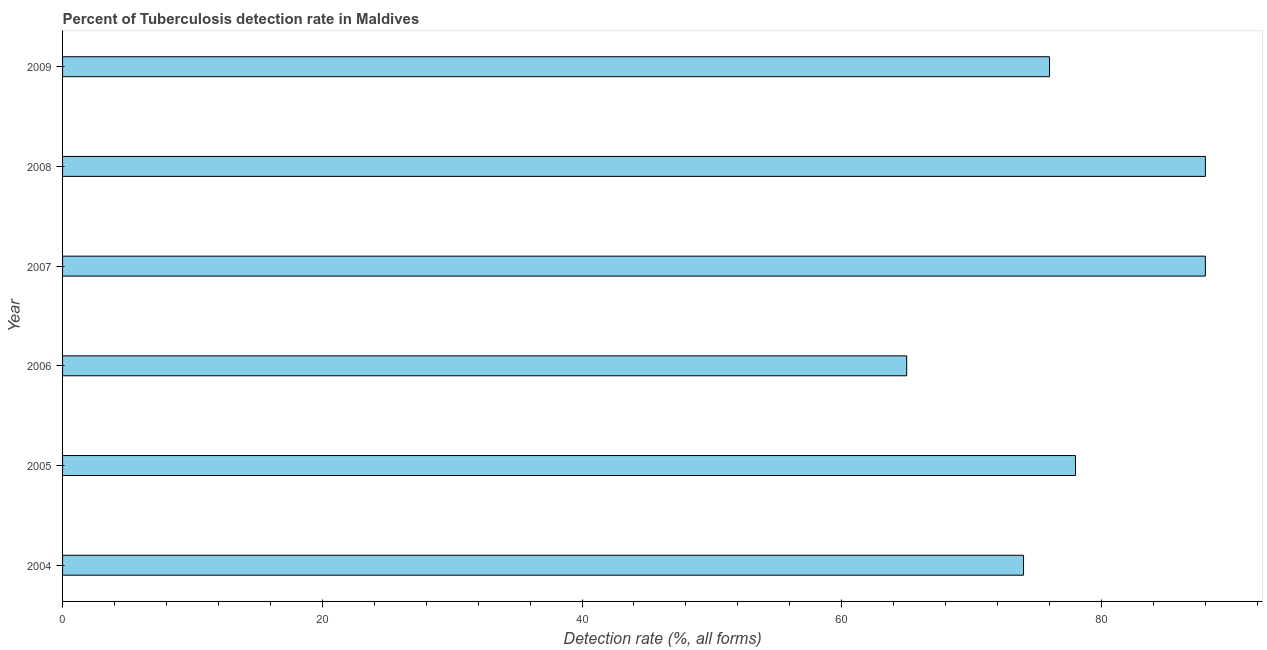Does the graph contain any zero values?
Your answer should be very brief. No. What is the title of the graph?
Provide a short and direct response. Percent of Tuberculosis detection rate in Maldives. What is the label or title of the X-axis?
Offer a terse response. Detection rate (%, all forms). Across all years, what is the maximum detection rate of tuberculosis?
Make the answer very short. 88. Across all years, what is the minimum detection rate of tuberculosis?
Your response must be concise. 65. In which year was the detection rate of tuberculosis maximum?
Your answer should be compact. 2007. In which year was the detection rate of tuberculosis minimum?
Offer a very short reply. 2006. What is the sum of the detection rate of tuberculosis?
Provide a succinct answer. 469. In how many years, is the detection rate of tuberculosis greater than 24 %?
Ensure brevity in your answer.  6. Do a majority of the years between 2009 and 2004 (inclusive) have detection rate of tuberculosis greater than 52 %?
Offer a very short reply. Yes. What is the ratio of the detection rate of tuberculosis in 2004 to that in 2007?
Your answer should be very brief. 0.84. Is the difference between the detection rate of tuberculosis in 2004 and 2007 greater than the difference between any two years?
Offer a terse response. No. What is the difference between the highest and the lowest detection rate of tuberculosis?
Provide a short and direct response. 23. How many bars are there?
Your answer should be compact. 6. Are all the bars in the graph horizontal?
Keep it short and to the point. Yes. How many years are there in the graph?
Give a very brief answer. 6. What is the difference between two consecutive major ticks on the X-axis?
Ensure brevity in your answer.  20. What is the Detection rate (%, all forms) of 2006?
Provide a succinct answer. 65. What is the difference between the Detection rate (%, all forms) in 2004 and 2007?
Provide a short and direct response. -14. What is the difference between the Detection rate (%, all forms) in 2004 and 2008?
Keep it short and to the point. -14. What is the difference between the Detection rate (%, all forms) in 2005 and 2007?
Offer a very short reply. -10. What is the difference between the Detection rate (%, all forms) in 2005 and 2008?
Your answer should be very brief. -10. What is the difference between the Detection rate (%, all forms) in 2006 and 2009?
Your answer should be very brief. -11. What is the difference between the Detection rate (%, all forms) in 2007 and 2009?
Ensure brevity in your answer.  12. What is the ratio of the Detection rate (%, all forms) in 2004 to that in 2005?
Ensure brevity in your answer.  0.95. What is the ratio of the Detection rate (%, all forms) in 2004 to that in 2006?
Offer a very short reply. 1.14. What is the ratio of the Detection rate (%, all forms) in 2004 to that in 2007?
Provide a succinct answer. 0.84. What is the ratio of the Detection rate (%, all forms) in 2004 to that in 2008?
Your response must be concise. 0.84. What is the ratio of the Detection rate (%, all forms) in 2005 to that in 2006?
Keep it short and to the point. 1.2. What is the ratio of the Detection rate (%, all forms) in 2005 to that in 2007?
Offer a very short reply. 0.89. What is the ratio of the Detection rate (%, all forms) in 2005 to that in 2008?
Your answer should be very brief. 0.89. What is the ratio of the Detection rate (%, all forms) in 2006 to that in 2007?
Make the answer very short. 0.74. What is the ratio of the Detection rate (%, all forms) in 2006 to that in 2008?
Ensure brevity in your answer.  0.74. What is the ratio of the Detection rate (%, all forms) in 2006 to that in 2009?
Provide a short and direct response. 0.85. What is the ratio of the Detection rate (%, all forms) in 2007 to that in 2009?
Your response must be concise. 1.16. What is the ratio of the Detection rate (%, all forms) in 2008 to that in 2009?
Your answer should be very brief. 1.16. 